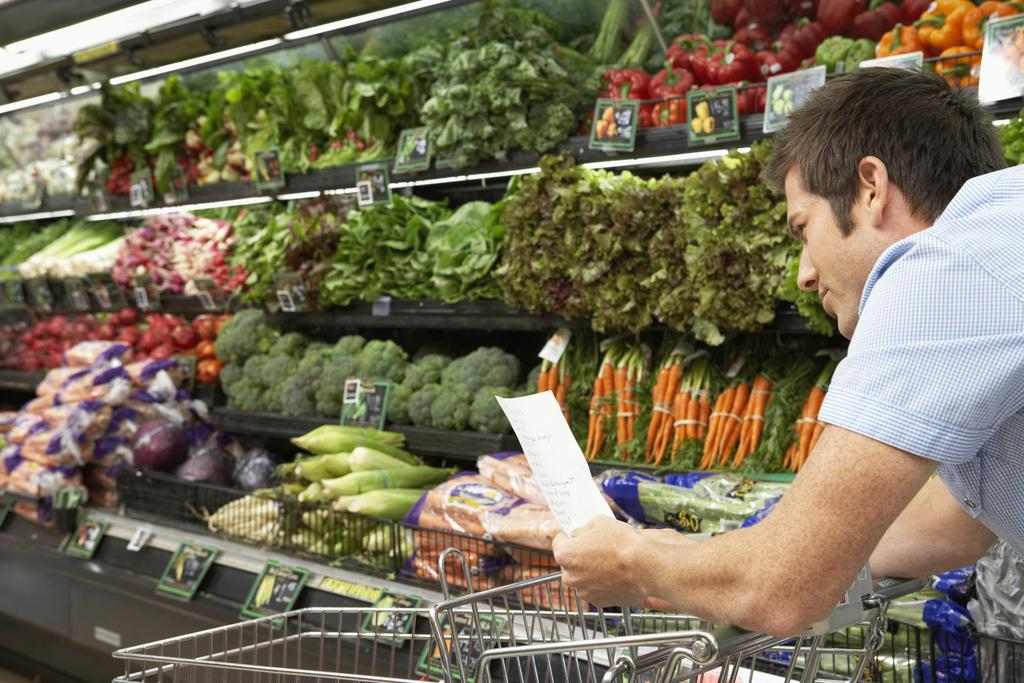What types of food items are visible in the image? There are vegetables and fruits in the image. How are the vegetables and fruits arranged in the image? The vegetables and fruits are in racks. What other objects can be seen in the image besides food items? There are cards with pictures and a trolley in the image. What is the person in the image doing? The person is holding a paper with text in the image. Where is the seat located in the image? There is no seat present in the image. Is there a fight happening between the vegetables and fruits in the image? No, there is no fight between the vegetables and fruits in the image; they are simply arranged in racks. 